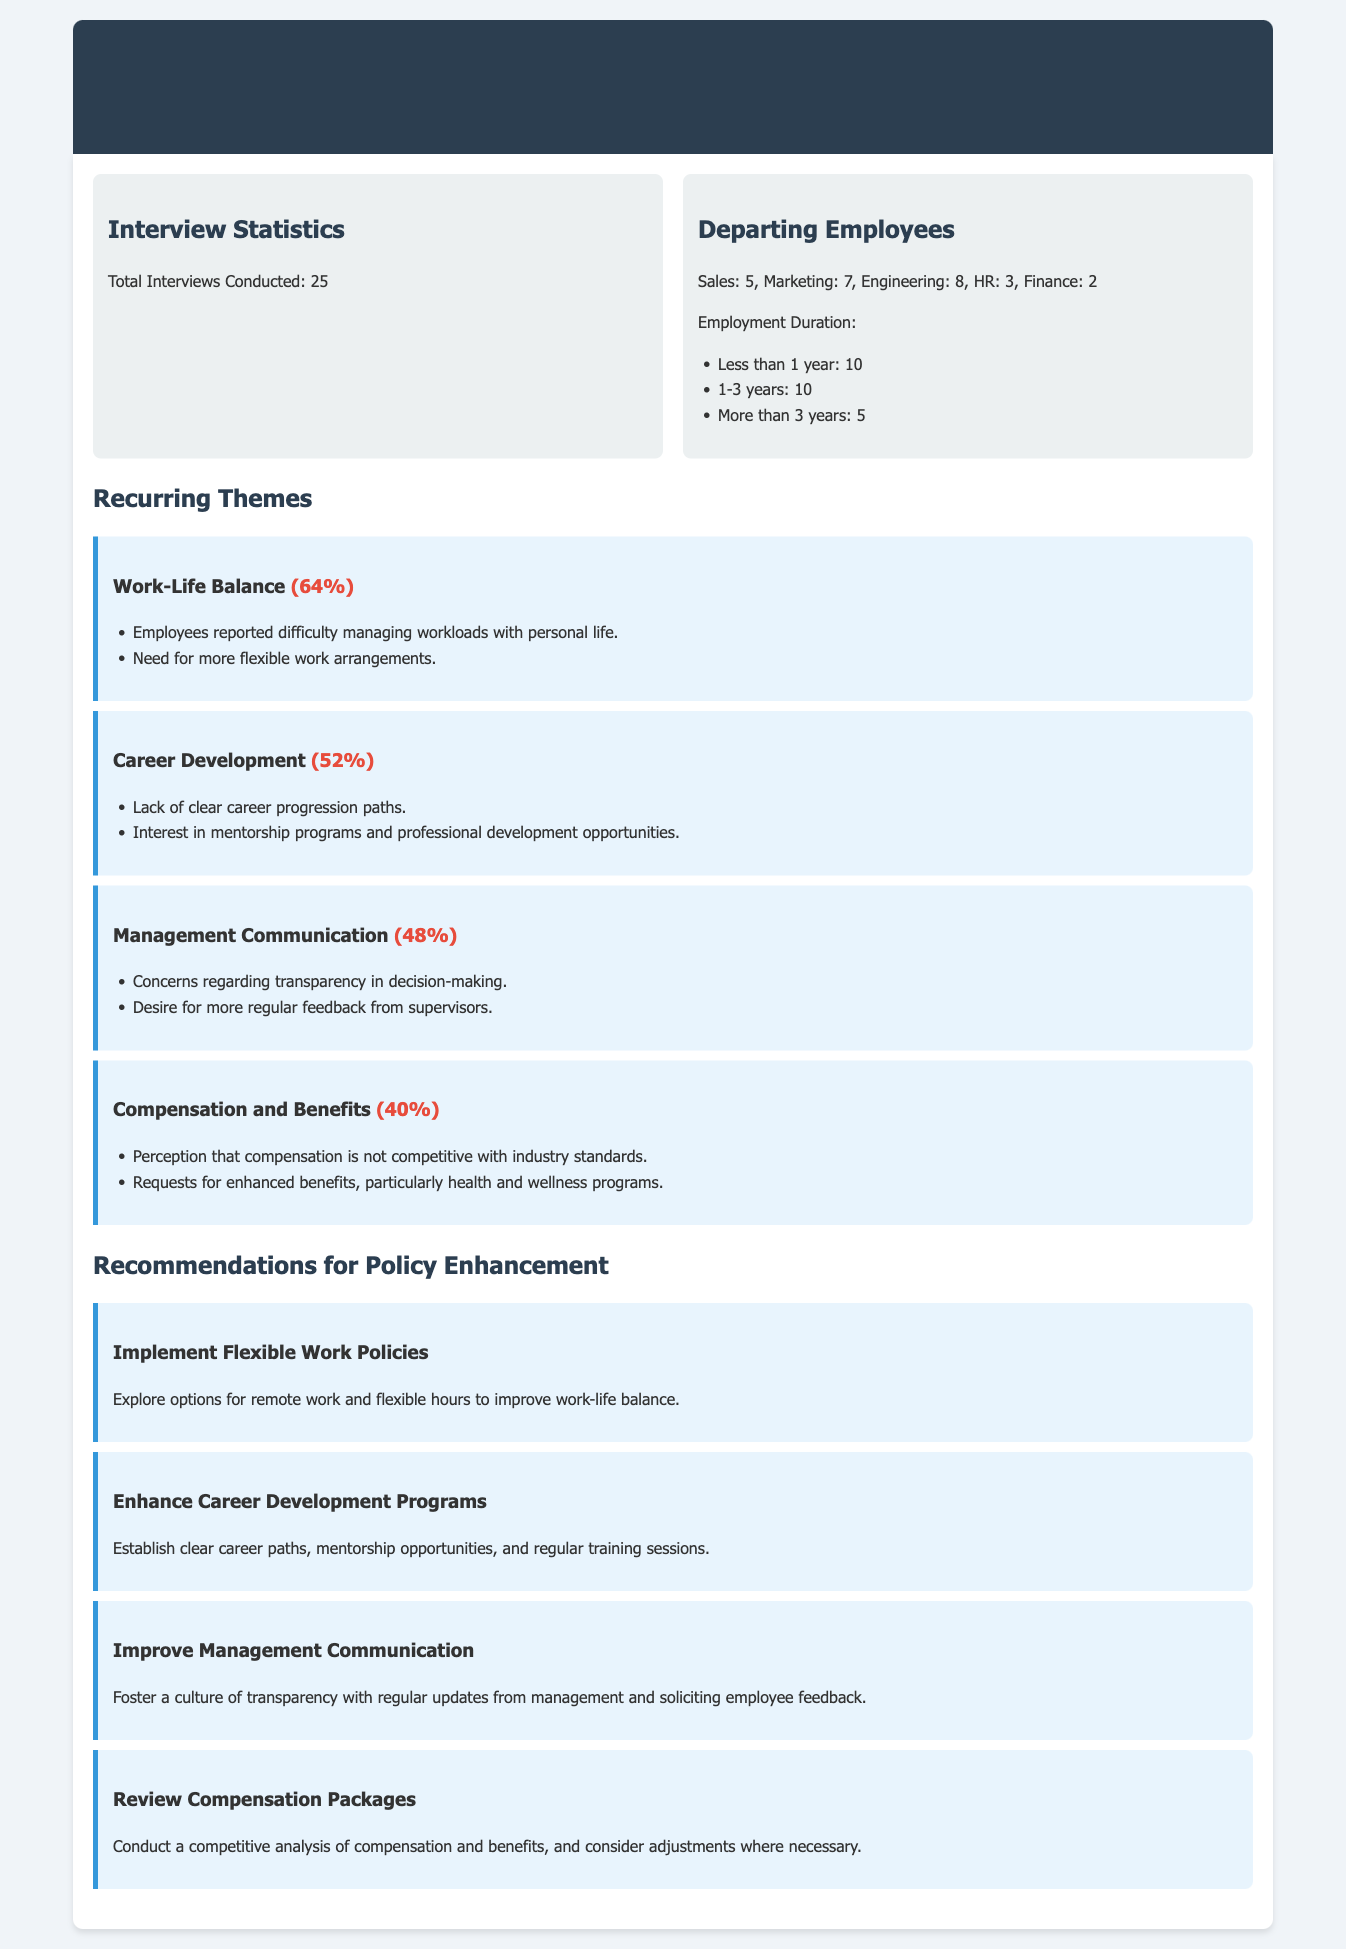What is the total number of interviews conducted? The total number of interviews conducted is stated in the "Interview Statistics" section of the document.
Answer: 25 What department had the highest number of departing employees? The document lists the number of departing employees by department; Engineering has the highest count.
Answer: Engineering What percentage of employees mentioned work-life balance as a recurring theme? Work-life balance is highlighted with a specific percentage in the "Recurring Themes" section.
Answer: 64% What is a key recommendation for improving career development? The document provides recommendations for policy enhancement, and one key area highlighted is career development.
Answer: Establish clear career paths What number of employees left after having worked for less than 1 year? The document specifies the employment duration of departing employees, particularly under 1 year.
Answer: 10 How many themes are mentioned in total? By referencing the "Recurring Themes" section, you can count the various themes addressed.
Answer: 4 What aspect of employee feedback is requested in the management communication theme? The specific concern regarding management communication is detailed in the "Recurring Themes" section.
Answer: Regular feedback What is the recommendation regarding compensation packages? The document suggests actions regarding compensation packages in the "Recommendations for Policy Enhancement" section.
Answer: Conduct a competitive analysis 